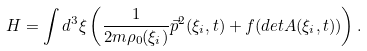<formula> <loc_0><loc_0><loc_500><loc_500>H = \int d ^ { 3 } \xi \left ( \frac { 1 } { 2 m \rho _ { 0 } ( \xi _ { i } ) } \vec { p } ^ { 2 } ( \xi _ { i } , t ) + f ( d e t A ( \xi _ { i } , t ) ) \right ) .</formula> 